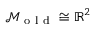<formula> <loc_0><loc_0><loc_500><loc_500>\mathcal { M } _ { o l d } \cong \mathbb { R } ^ { 2 }</formula> 